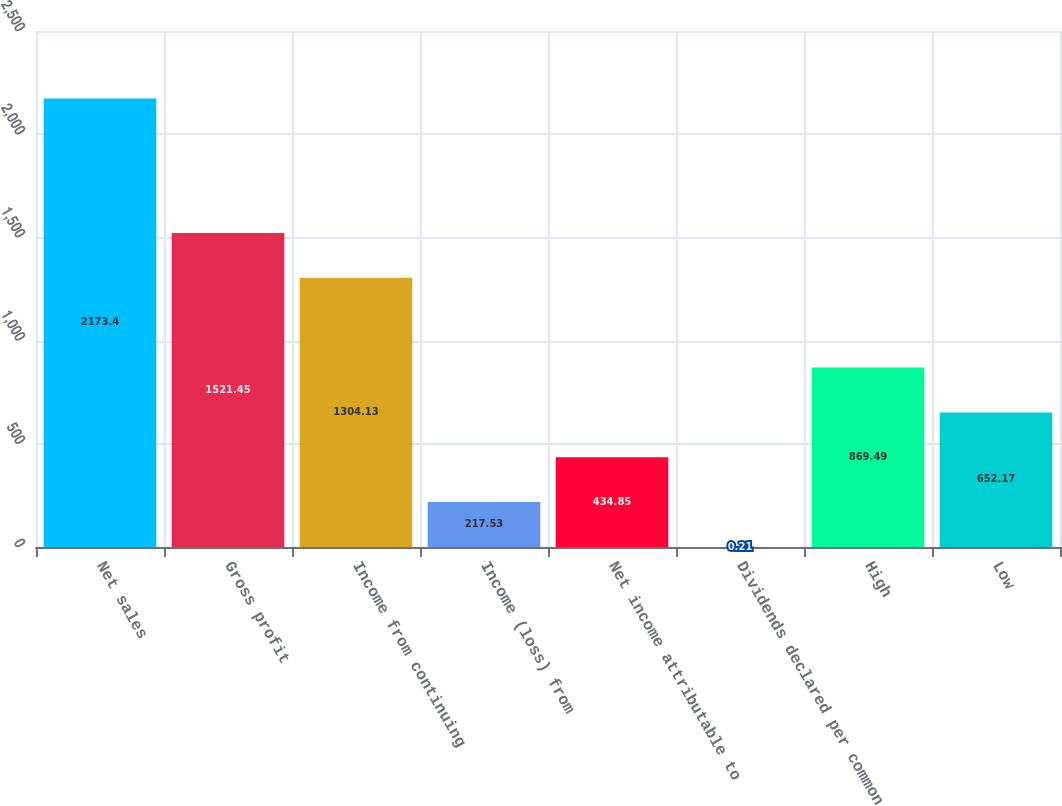<chart> <loc_0><loc_0><loc_500><loc_500><bar_chart><fcel>Net sales<fcel>Gross profit<fcel>Income from continuing<fcel>Income (loss) from<fcel>Net income attributable to<fcel>Dividends declared per common<fcel>High<fcel>Low<nl><fcel>2173.4<fcel>1521.45<fcel>1304.13<fcel>217.53<fcel>434.85<fcel>0.21<fcel>869.49<fcel>652.17<nl></chart> 